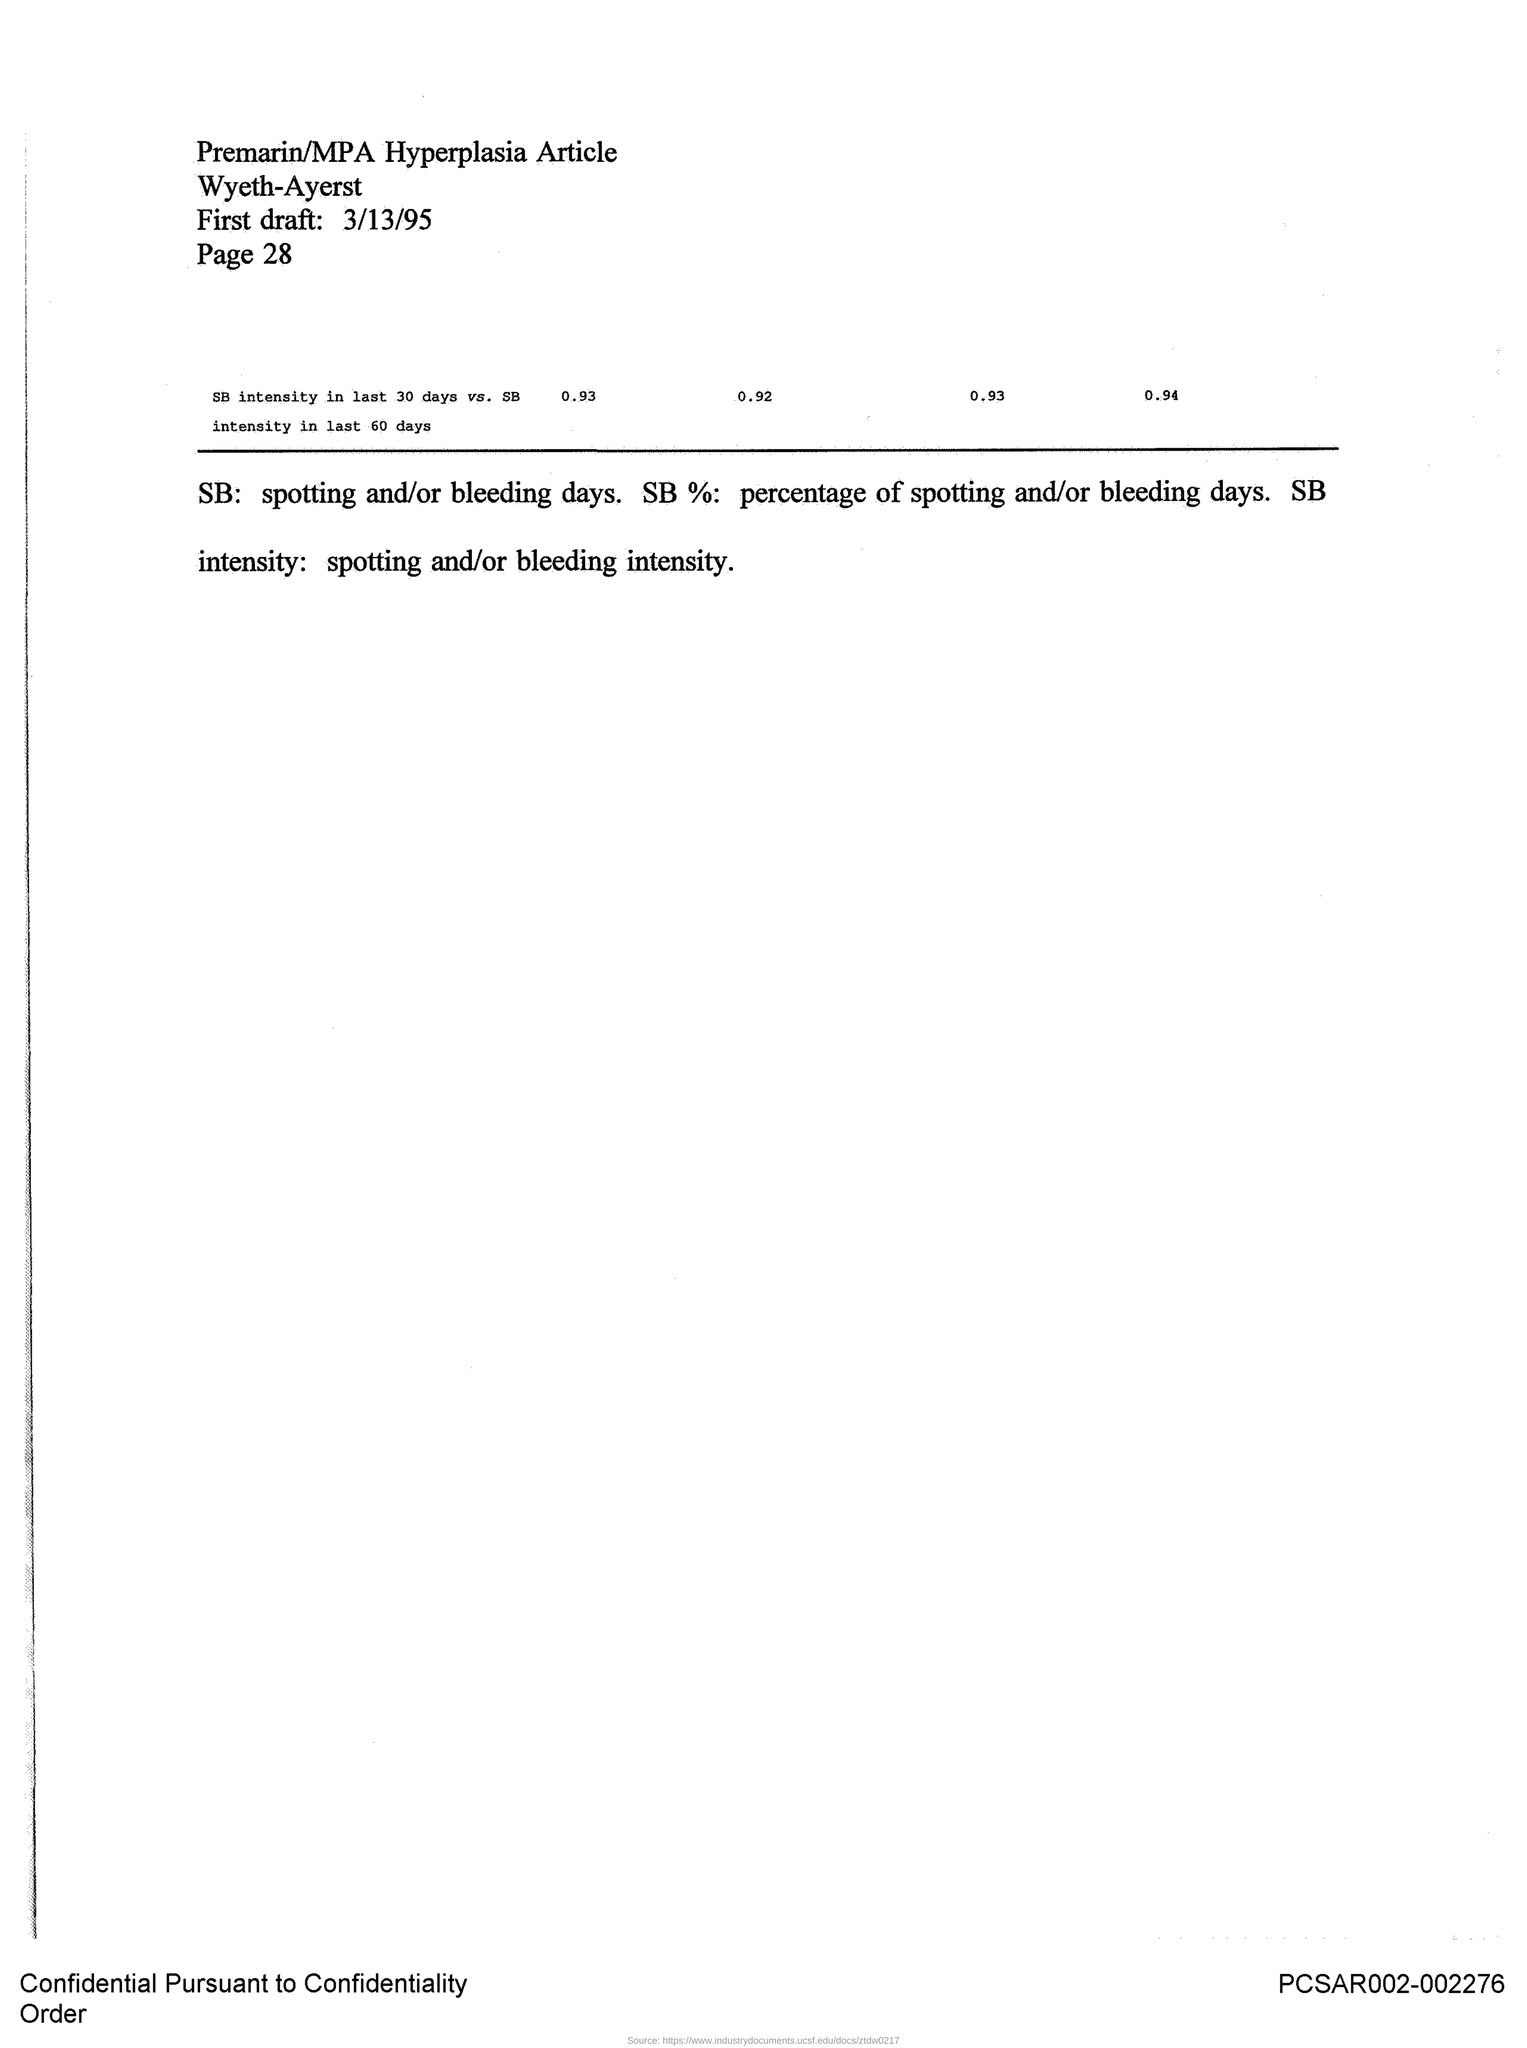What is the name of the article?
Your response must be concise. Premarin/MPA Hyperplasia Article. When was the first draft drafted?
Your answer should be very brief. 3/13/95. 